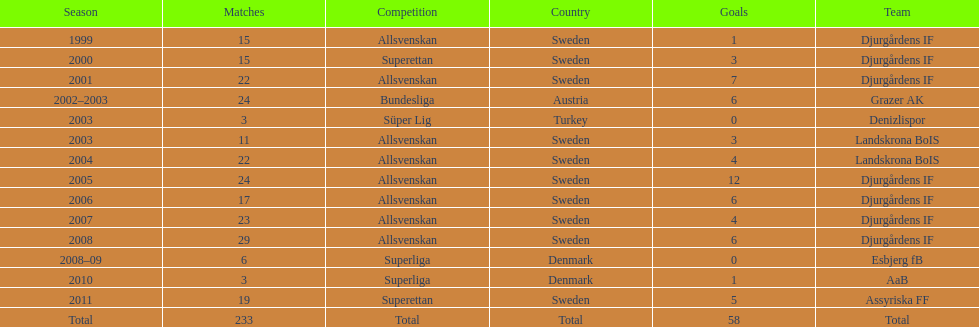What was the number of goals he scored in 2005? 12. 